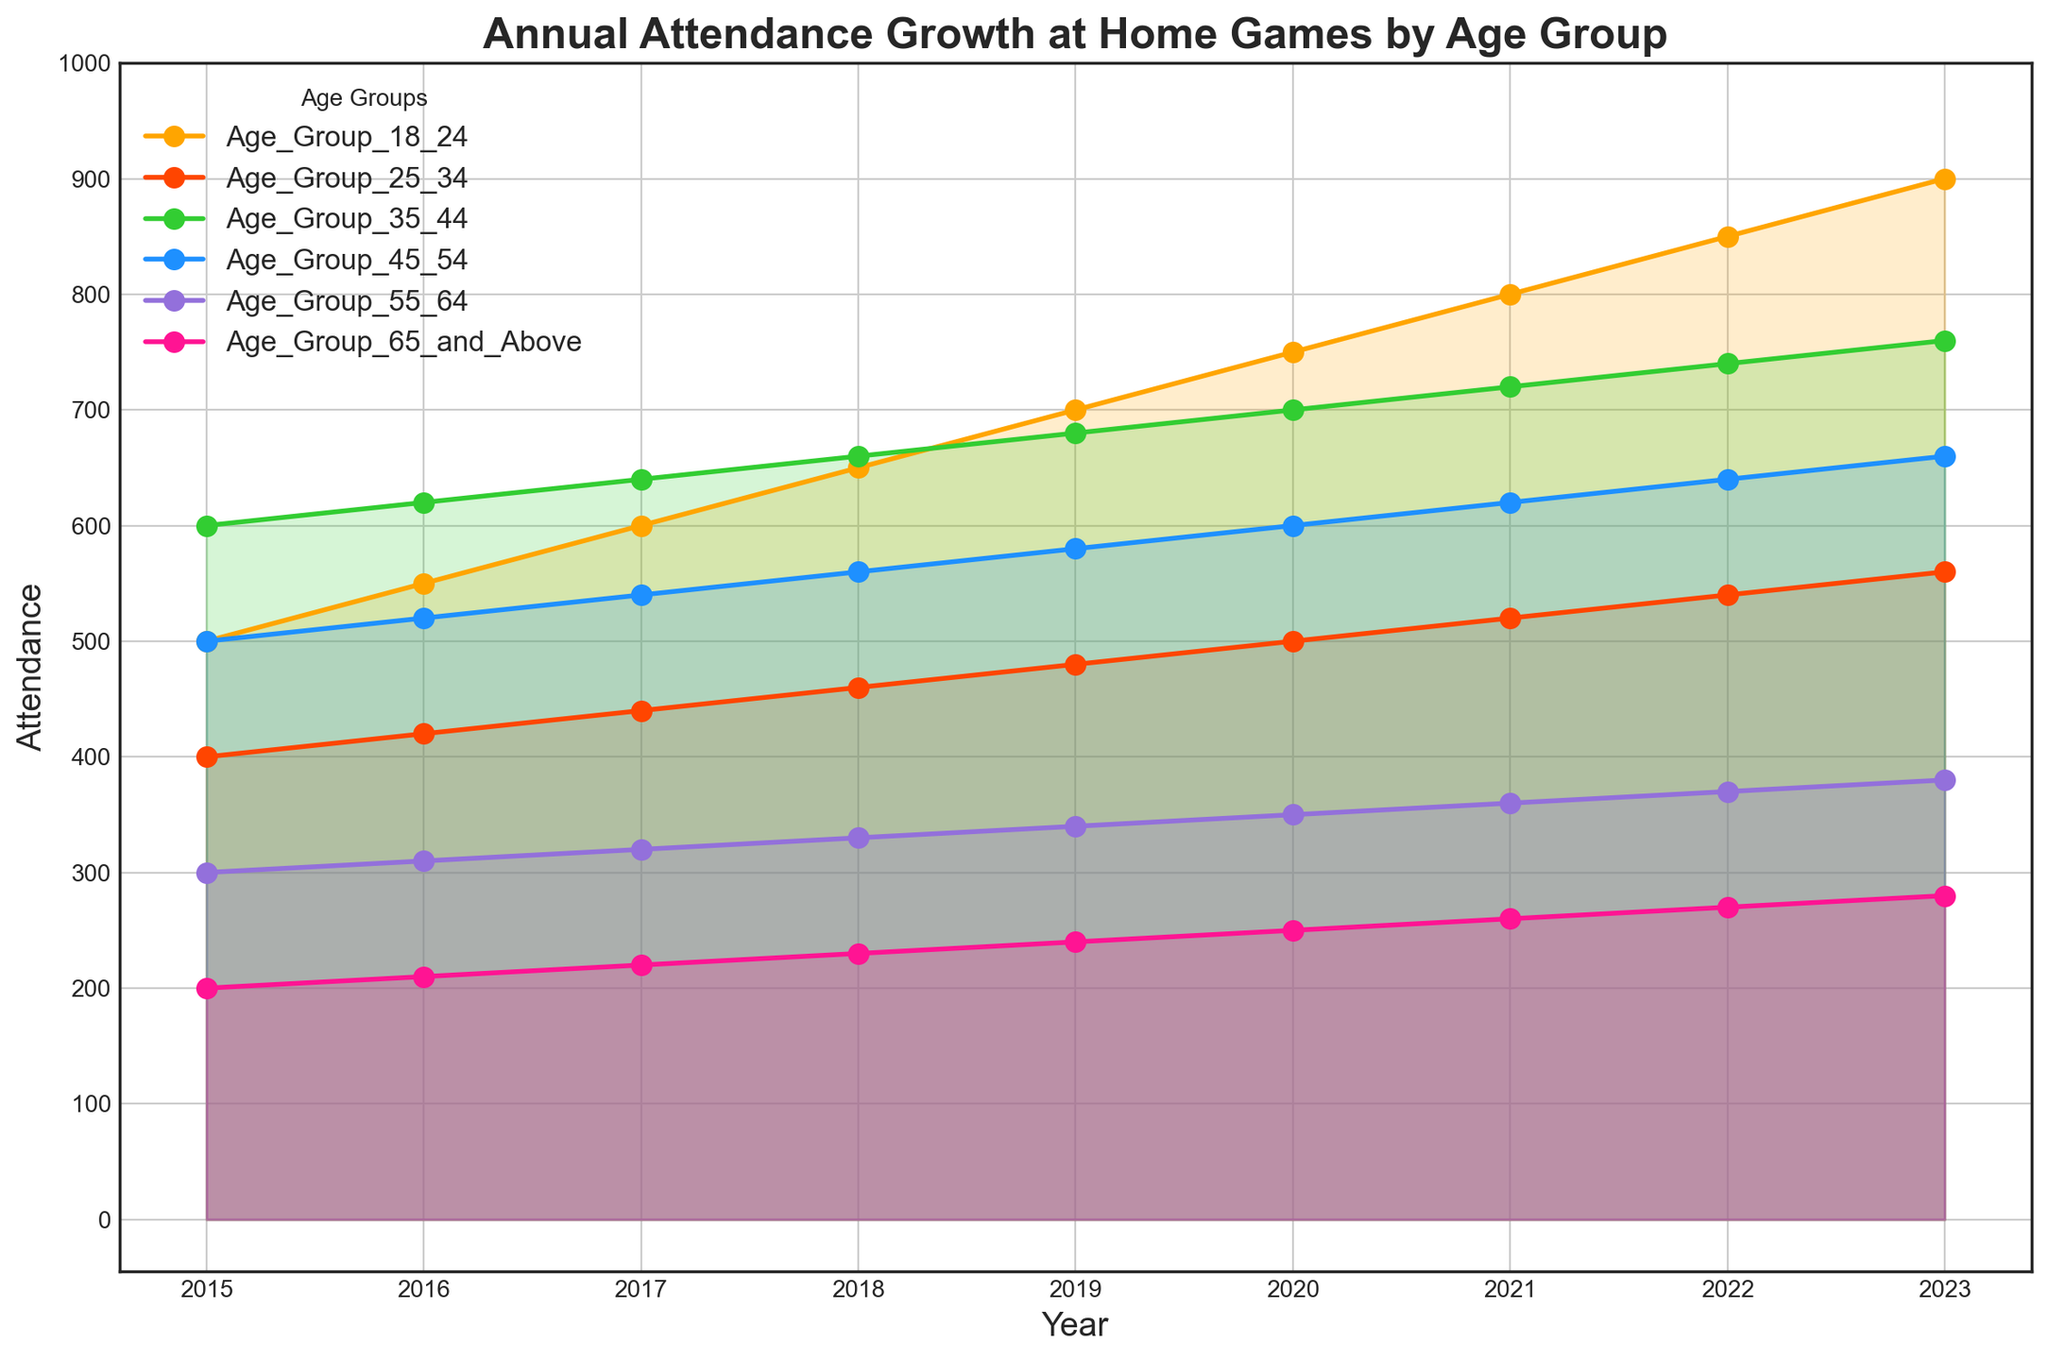What age group had the highest attendance in 2023? To find the highest attendance in 2023, look at 2023 in the x-axis and see which age group line is at the highest point. The Age Group 18-24 has the highest value of 900.
Answer: Age Group 18-24 Compare the attendance of Age Group 25-34 and Age Group 45-54 in 2020. Which is higher? To compare attendance in 2020, look at the y-axis values for Age Group 25-34 and Age Group 45-54. Age Group 25-34 is at 500, while Age Group 45-54 is at 600. So, Age Group 45-54 has higher attendance.
Answer: Age Group 45-54 What is the average attendance for Age Group 35-44 over the years 2015 to 2023? To calculate the average, sum up the attendance values of Age Group 35-44 from 2015 to 2023 (600 + 620 + 640 + 660 + 680 + 700 + 720 + 740 + 760) and divide by the total number of years (9). The sum is 6120, so the average is 6120 / 9 = 680.
Answer: 680 By how much did the attendance for Age Group 18-24 increase from 2015 to 2023? To find the increase, subtract the 2015 value from the 2023 value for Age Group 18-24. The values are 900 in 2023 and 500 in 2015. So, the increase is 900 - 500 = 400.
Answer: 400 Which two age groups had the least difference in attendance in 2019? Examine the y-axis values for all age groups in 2019 and determine the smallest difference. Age Group 55-64 has 340, and Age Group 65 and Above has 240, with a difference of 100, which is the smallest among all pairs.
Answer: Age Group 55-64 and Age Group 65 and Above What is the attendance trend for Age Group 55-64 from 2015 to 2023? Observe the trend line for Age Group 55-64 from 2015 to 2023. The line shows a steady increase from 300 in 2015 to 380 in 2023.
Answer: Steady increase Which age group had the smallest attendance drop after 2020? Find any age groups that maintained or decreased attendance slightly after 2020. All age groups continue to increase; thus, there’s no drop in attendance for any group after 2020.
Answer: No drop for any age group If we combine the attendances of Age Groups 18-24 and 25-34 in 2022, what is the total attendance? To combine the attendances, add the values for Age Group 18-24 and Age Group 25-34 in 2022. The numbers are 850 and 540 respectively, so the total is 850 + 540 = 1390.
Answer: 1390 Which year saw the highest overall attendance across all age groups? Sum each age group's attendance for each year and identify the year with the highest total. The sum for 2023 is the highest: 900 + 560 + 760 + 660 + 380 + 280 = 3540.
Answer: 2023 